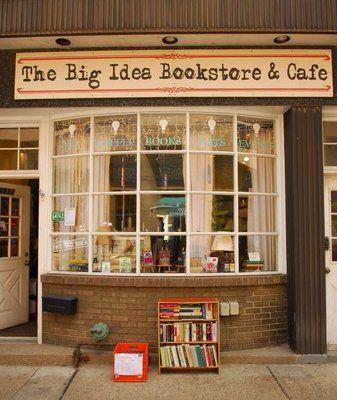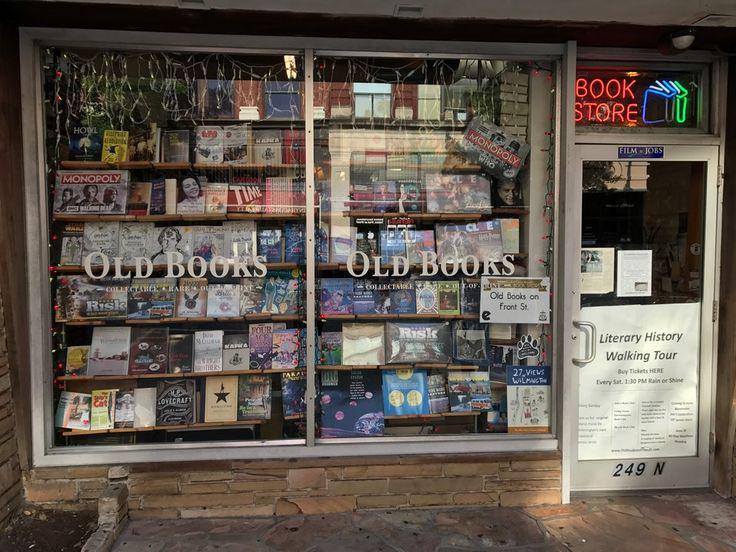The first image is the image on the left, the second image is the image on the right. Examine the images to the left and right. Is the description "There are human beings visible in at least one image." accurate? Answer yes or no. No. The first image is the image on the left, the second image is the image on the right. Examine the images to the left and right. Is the description "In at least one image there is a door and two window at the front of the bookstore." accurate? Answer yes or no. Yes. 